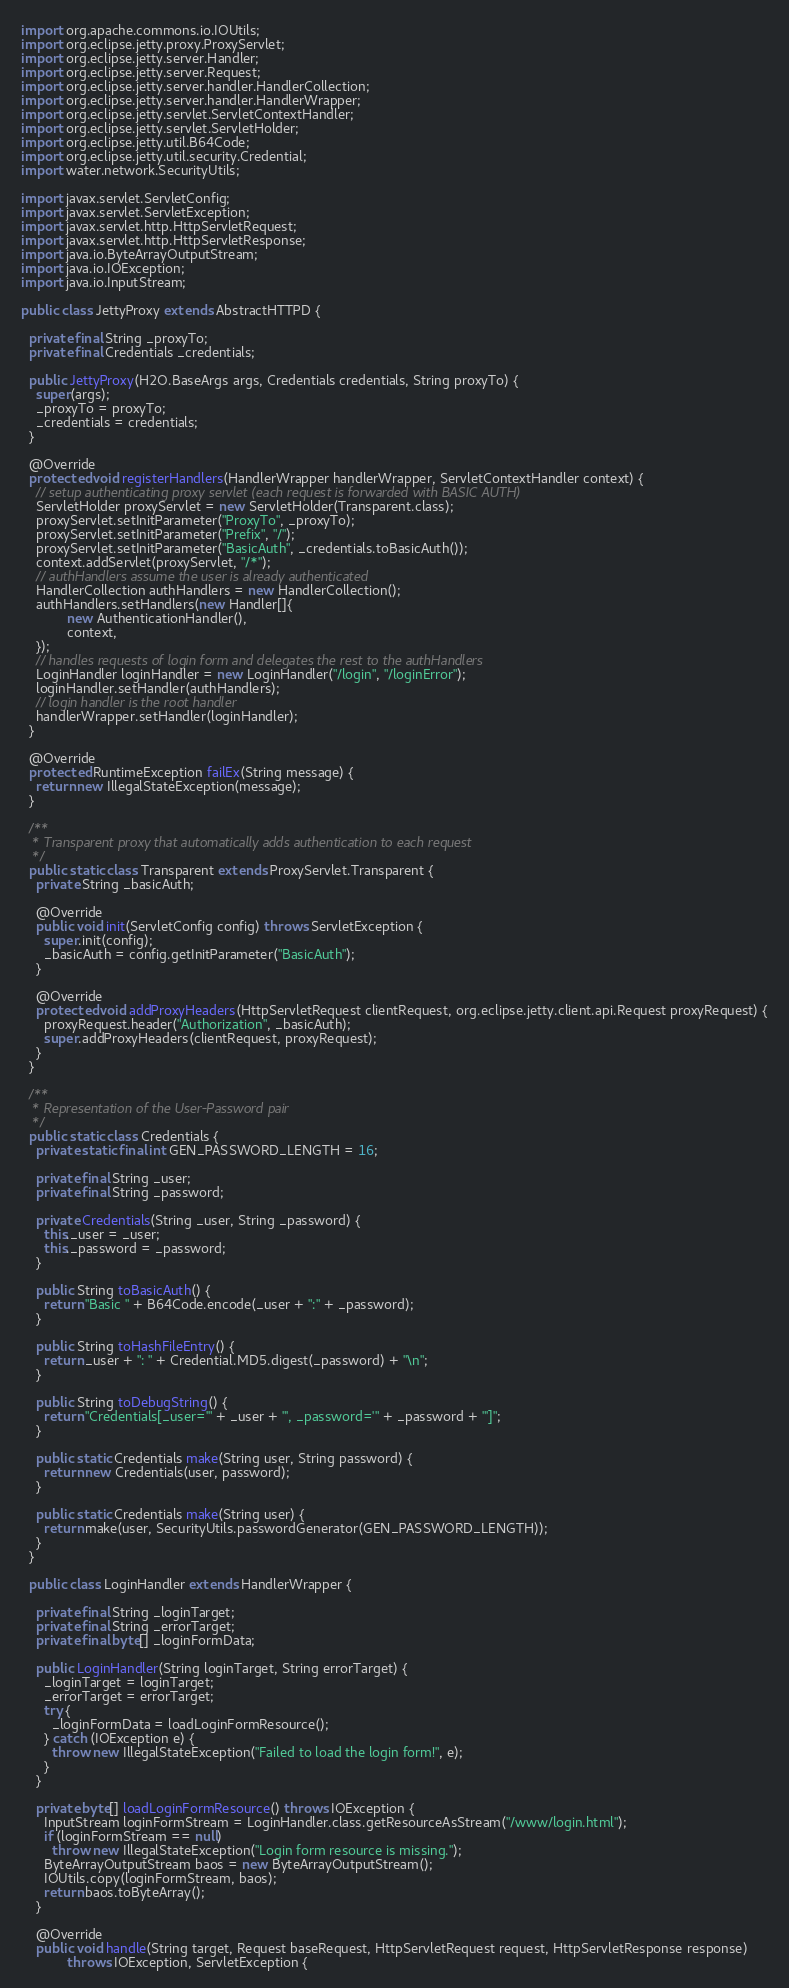<code> <loc_0><loc_0><loc_500><loc_500><_Java_>import org.apache.commons.io.IOUtils;
import org.eclipse.jetty.proxy.ProxyServlet;
import org.eclipse.jetty.server.Handler;
import org.eclipse.jetty.server.Request;
import org.eclipse.jetty.server.handler.HandlerCollection;
import org.eclipse.jetty.server.handler.HandlerWrapper;
import org.eclipse.jetty.servlet.ServletContextHandler;
import org.eclipse.jetty.servlet.ServletHolder;
import org.eclipse.jetty.util.B64Code;
import org.eclipse.jetty.util.security.Credential;
import water.network.SecurityUtils;

import javax.servlet.ServletConfig;
import javax.servlet.ServletException;
import javax.servlet.http.HttpServletRequest;
import javax.servlet.http.HttpServletResponse;
import java.io.ByteArrayOutputStream;
import java.io.IOException;
import java.io.InputStream;

public class JettyProxy extends AbstractHTTPD {

  private final String _proxyTo;
  private final Credentials _credentials;

  public JettyProxy(H2O.BaseArgs args, Credentials credentials, String proxyTo) {
    super(args);
    _proxyTo = proxyTo;
    _credentials = credentials;
  }

  @Override
  protected void registerHandlers(HandlerWrapper handlerWrapper, ServletContextHandler context) {
    // setup authenticating proxy servlet (each request is forwarded with BASIC AUTH)
    ServletHolder proxyServlet = new ServletHolder(Transparent.class);
    proxyServlet.setInitParameter("ProxyTo", _proxyTo);
    proxyServlet.setInitParameter("Prefix", "/");
    proxyServlet.setInitParameter("BasicAuth", _credentials.toBasicAuth());
    context.addServlet(proxyServlet, "/*");
    // authHandlers assume the user is already authenticated
    HandlerCollection authHandlers = new HandlerCollection();
    authHandlers.setHandlers(new Handler[]{
            new AuthenticationHandler(),
            context,
    });
    // handles requests of login form and delegates the rest to the authHandlers
    LoginHandler loginHandler = new LoginHandler("/login", "/loginError");
    loginHandler.setHandler(authHandlers);
    // login handler is the root handler
    handlerWrapper.setHandler(loginHandler);
  }

  @Override
  protected RuntimeException failEx(String message) {
    return new IllegalStateException(message);
  }

  /**
   * Transparent proxy that automatically adds authentication to each request
   */
  public static class Transparent extends ProxyServlet.Transparent {
    private String _basicAuth;

    @Override
    public void init(ServletConfig config) throws ServletException {
      super.init(config);
      _basicAuth = config.getInitParameter("BasicAuth");
    }

    @Override
    protected void addProxyHeaders(HttpServletRequest clientRequest, org.eclipse.jetty.client.api.Request proxyRequest) {
      proxyRequest.header("Authorization", _basicAuth);
      super.addProxyHeaders(clientRequest, proxyRequest);
    }
  }

  /**
   * Representation of the User-Password pair
   */
  public static class Credentials {
    private static final int GEN_PASSWORD_LENGTH = 16;

    private final String _user;
    private final String _password;

    private Credentials(String _user, String _password) {
      this._user = _user;
      this._password = _password;
    }

    public String toBasicAuth() {
      return "Basic " + B64Code.encode(_user + ":" + _password);
    }

    public String toHashFileEntry() {
      return _user + ": " + Credential.MD5.digest(_password) + "\n";
    }

    public String toDebugString() {
      return "Credentials[_user='" + _user + "', _password='" + _password + "']";
    }

    public static Credentials make(String user, String password) {
      return new Credentials(user, password);
    }

    public static Credentials make(String user) {
      return make(user, SecurityUtils.passwordGenerator(GEN_PASSWORD_LENGTH));
    }
  }

  public class LoginHandler extends HandlerWrapper {

    private final String _loginTarget;
    private final String _errorTarget;
    private final byte[] _loginFormData;

    public LoginHandler(String loginTarget, String errorTarget) {
      _loginTarget = loginTarget;
      _errorTarget = errorTarget;
      try {
        _loginFormData = loadLoginFormResource();
      } catch (IOException e) {
        throw new IllegalStateException("Failed to load the login form!", e);
      }
    }

    private byte[] loadLoginFormResource() throws IOException {
      InputStream loginFormStream = LoginHandler.class.getResourceAsStream("/www/login.html");
      if (loginFormStream == null)
        throw new IllegalStateException("Login form resource is missing.");
      ByteArrayOutputStream baos = new ByteArrayOutputStream();
      IOUtils.copy(loginFormStream, baos);
      return baos.toByteArray();
    }

    @Override
    public void handle(String target, Request baseRequest, HttpServletRequest request, HttpServletResponse response)
            throws IOException, ServletException {</code> 